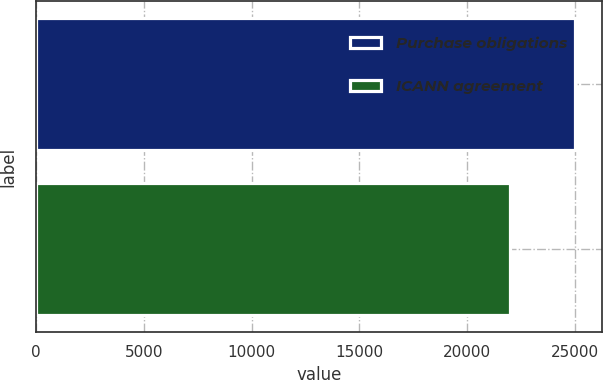<chart> <loc_0><loc_0><loc_500><loc_500><bar_chart><fcel>Purchase obligations<fcel>ICANN agreement<nl><fcel>25030<fcel>22000<nl></chart> 